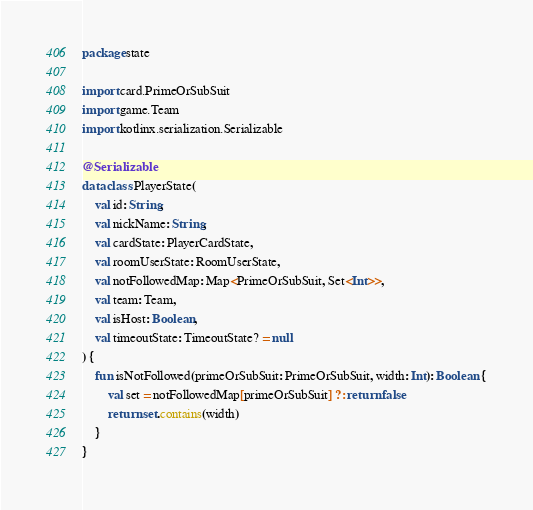<code> <loc_0><loc_0><loc_500><loc_500><_Kotlin_>package state

import card.PrimeOrSubSuit
import game.Team
import kotlinx.serialization.Serializable

@Serializable
data class PlayerState(
    val id: String,
    val nickName: String,
    val cardState: PlayerCardState,
    val roomUserState: RoomUserState,
    val notFollowedMap: Map<PrimeOrSubSuit, Set<Int>>,
    val team: Team,
    val isHost: Boolean,
    val timeoutState: TimeoutState? = null
) {
    fun isNotFollowed(primeOrSubSuit: PrimeOrSubSuit, width: Int): Boolean {
        val set = notFollowedMap[primeOrSubSuit] ?: return false
        return set.contains(width)
    }
}</code> 